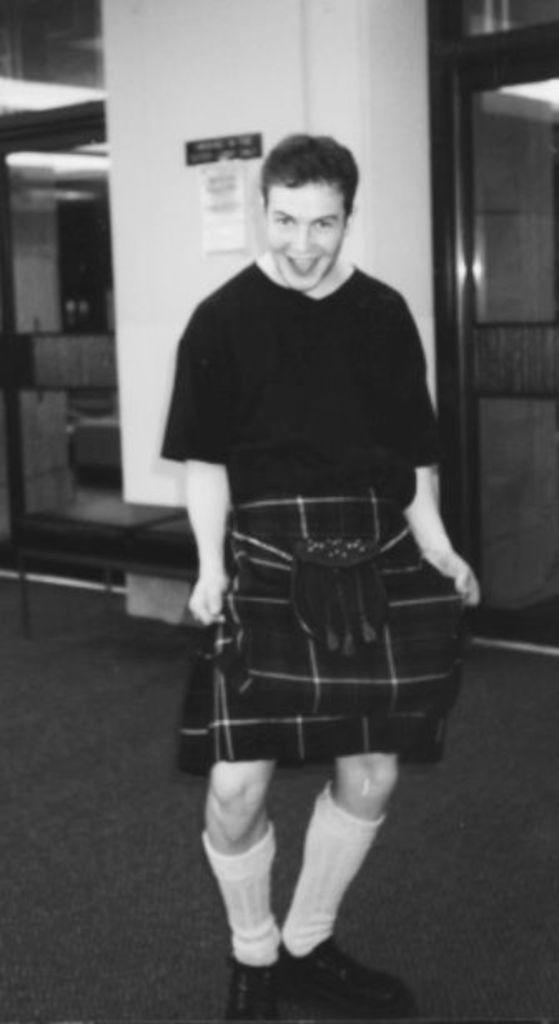Who is the main subject in the image? There is a man in the center of the image. What is the man doing in the image? The man is standing and smiling. What can be seen in the background of the image? There is a wall and a door in the background of the image. What type of experience does the doll have with the crow in the image? There is no doll or crow present in the image. 